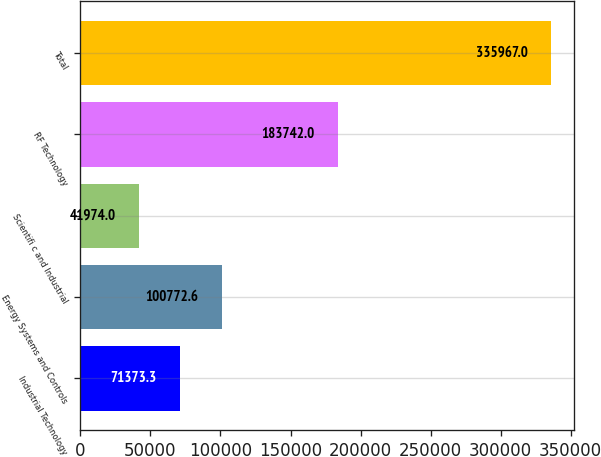<chart> <loc_0><loc_0><loc_500><loc_500><bar_chart><fcel>Industrial Technology<fcel>Energy Systems and Controls<fcel>Scientifi c and Industrial<fcel>RF Technology<fcel>Total<nl><fcel>71373.3<fcel>100773<fcel>41974<fcel>183742<fcel>335967<nl></chart> 